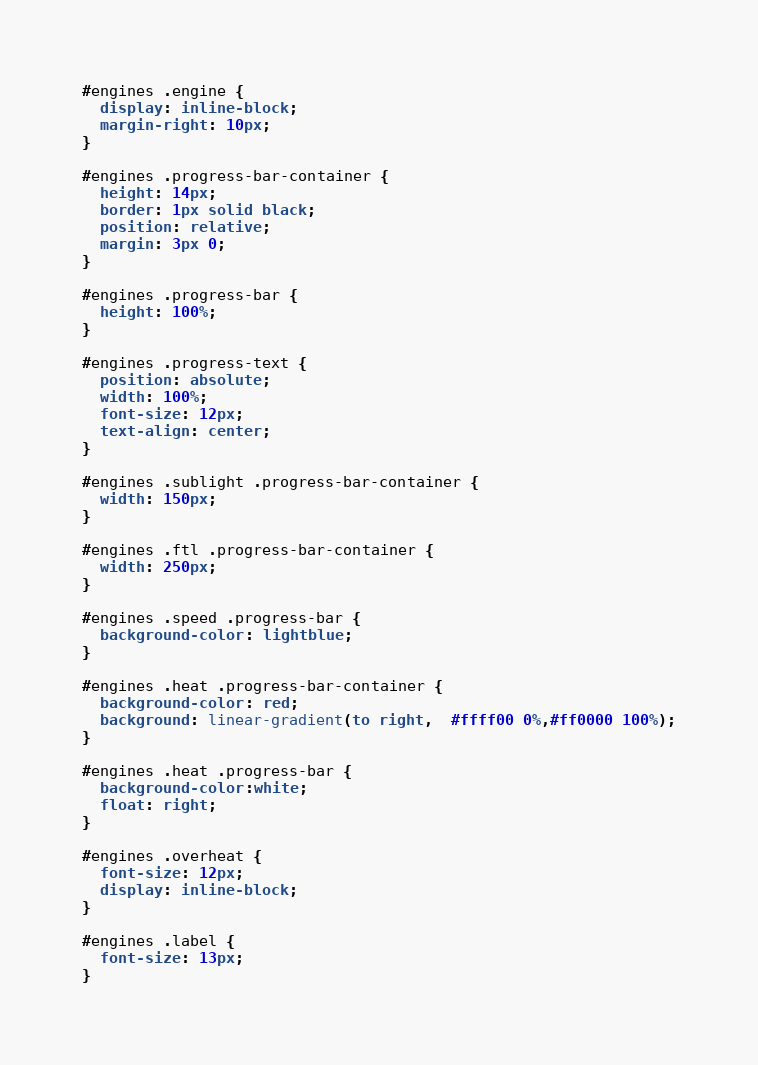Convert code to text. <code><loc_0><loc_0><loc_500><loc_500><_CSS_>#engines .engine {
  display: inline-block;
  margin-right: 10px;
}

#engines .progress-bar-container {
  height: 14px;
  border: 1px solid black;
  position: relative;
  margin: 3px 0;
}

#engines .progress-bar {
  height: 100%;
}

#engines .progress-text {
  position: absolute;
  width: 100%;
  font-size: 12px;
  text-align: center;
}

#engines .sublight .progress-bar-container {
  width: 150px;
}

#engines .ftl .progress-bar-container {
  width: 250px;
}

#engines .speed .progress-bar {
  background-color: lightblue;
}

#engines .heat .progress-bar-container {
  background-color: red;
  background: linear-gradient(to right,  #ffff00 0%,#ff0000 100%);
}

#engines .heat .progress-bar {
  background-color:white;
  float: right;
}

#engines .overheat {
  font-size: 12px;
  display: inline-block;
}

#engines .label {
  font-size: 13px;
}
</code> 